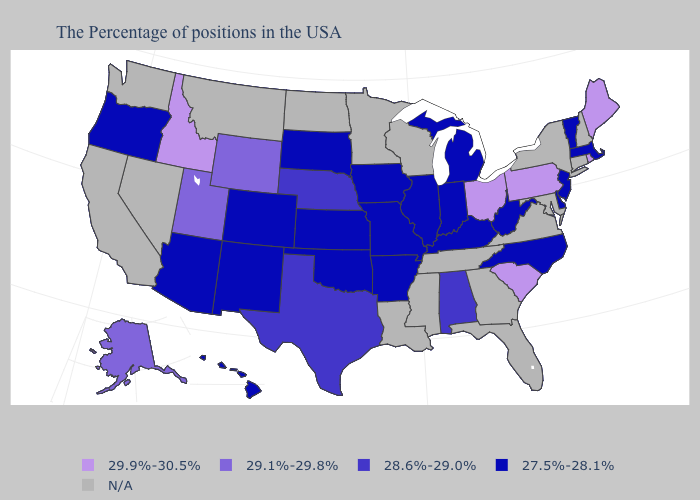Among the states that border West Virginia , which have the highest value?
Keep it brief. Pennsylvania, Ohio. Does the map have missing data?
Quick response, please. Yes. Among the states that border Utah , which have the lowest value?
Be succinct. Colorado, New Mexico, Arizona. Name the states that have a value in the range 27.5%-28.1%?
Concise answer only. Massachusetts, Vermont, New Jersey, Delaware, North Carolina, West Virginia, Michigan, Kentucky, Indiana, Illinois, Missouri, Arkansas, Iowa, Kansas, Oklahoma, South Dakota, Colorado, New Mexico, Arizona, Oregon, Hawaii. Name the states that have a value in the range 28.6%-29.0%?
Write a very short answer. Alabama, Nebraska, Texas. What is the value of Washington?
Keep it brief. N/A. Among the states that border Oklahoma , which have the lowest value?
Short answer required. Missouri, Arkansas, Kansas, Colorado, New Mexico. What is the value of New York?
Write a very short answer. N/A. What is the value of Vermont?
Short answer required. 27.5%-28.1%. Name the states that have a value in the range 27.5%-28.1%?
Write a very short answer. Massachusetts, Vermont, New Jersey, Delaware, North Carolina, West Virginia, Michigan, Kentucky, Indiana, Illinois, Missouri, Arkansas, Iowa, Kansas, Oklahoma, South Dakota, Colorado, New Mexico, Arizona, Oregon, Hawaii. What is the value of Alabama?
Quick response, please. 28.6%-29.0%. Among the states that border Kansas , does Colorado have the lowest value?
Short answer required. Yes. 